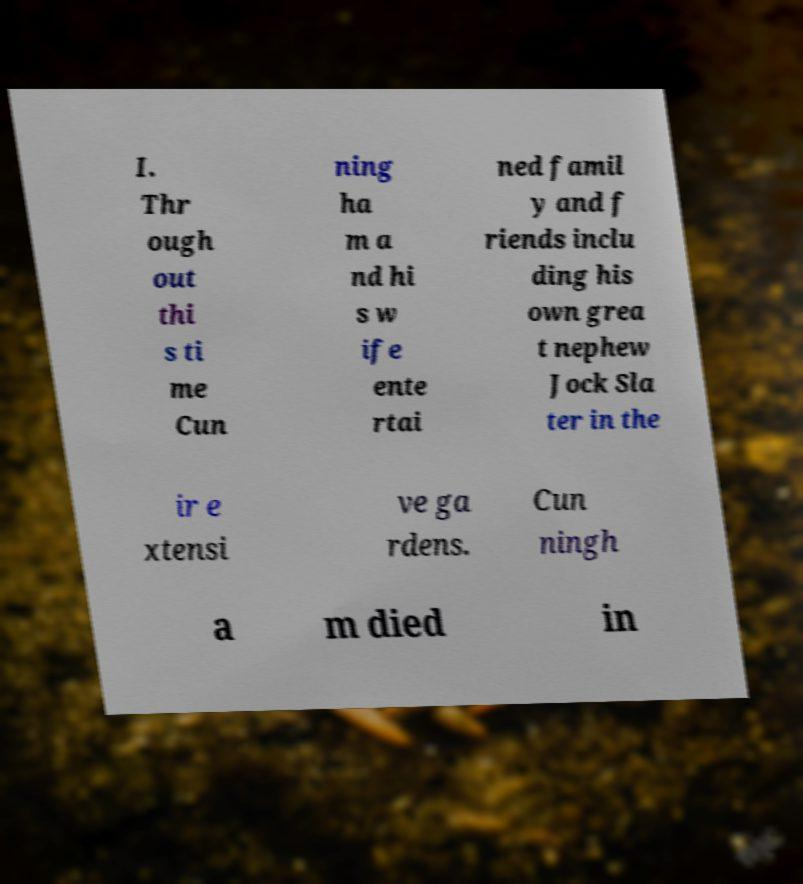Please identify and transcribe the text found in this image. I. Thr ough out thi s ti me Cun ning ha m a nd hi s w ife ente rtai ned famil y and f riends inclu ding his own grea t nephew Jock Sla ter in the ir e xtensi ve ga rdens. Cun ningh a m died in 